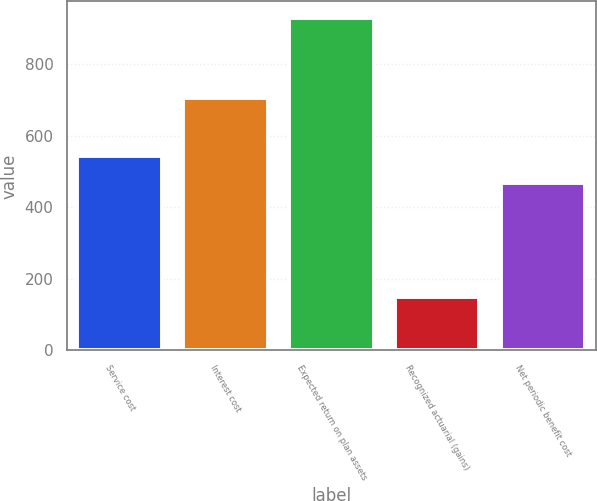Convert chart to OTSL. <chart><loc_0><loc_0><loc_500><loc_500><bar_chart><fcel>Service cost<fcel>Interest cost<fcel>Expected return on plan assets<fcel>Recognized actuarial (gains)<fcel>Net periodic benefit cost<nl><fcel>545<fcel>707<fcel>930<fcel>150<fcel>467<nl></chart> 